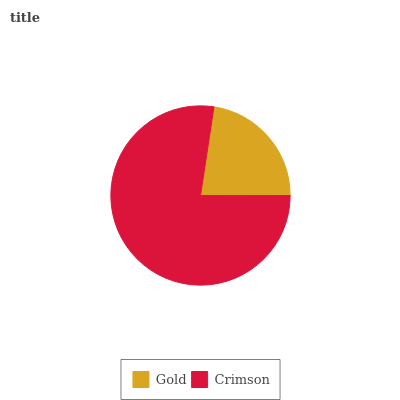Is Gold the minimum?
Answer yes or no. Yes. Is Crimson the maximum?
Answer yes or no. Yes. Is Crimson the minimum?
Answer yes or no. No. Is Crimson greater than Gold?
Answer yes or no. Yes. Is Gold less than Crimson?
Answer yes or no. Yes. Is Gold greater than Crimson?
Answer yes or no. No. Is Crimson less than Gold?
Answer yes or no. No. Is Crimson the high median?
Answer yes or no. Yes. Is Gold the low median?
Answer yes or no. Yes. Is Gold the high median?
Answer yes or no. No. Is Crimson the low median?
Answer yes or no. No. 